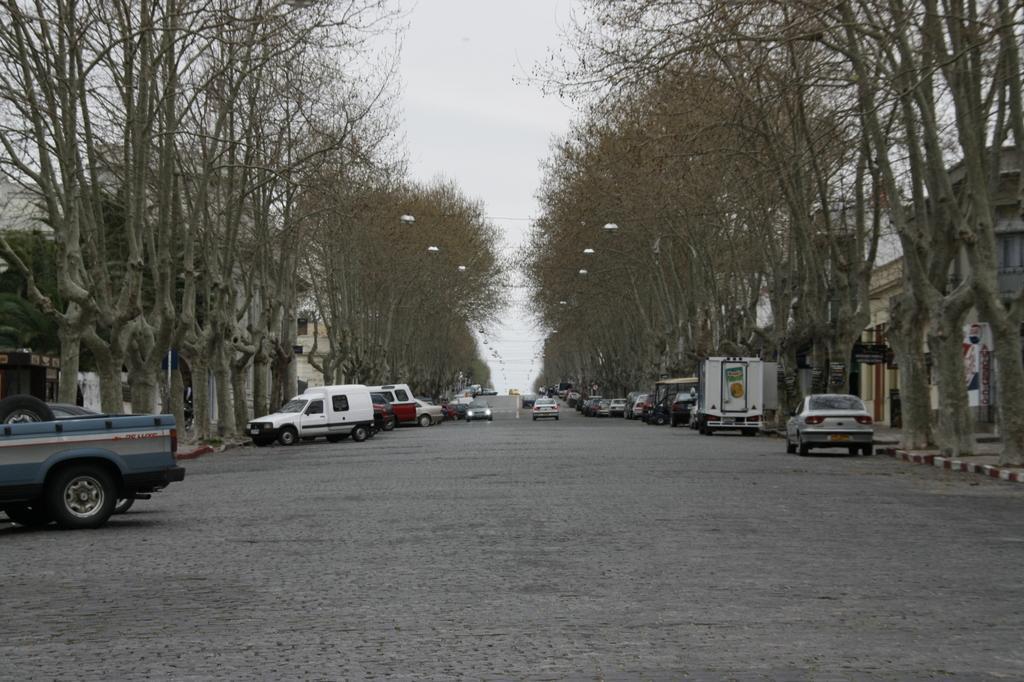Can you describe this image briefly? In this image in the center there are some vehicles, and at the bottom there is road. On the right side and left side there are trees, buildings and some lights, wires, boards, and at the top of the image there is sky. 